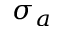<formula> <loc_0><loc_0><loc_500><loc_500>\sigma _ { a }</formula> 